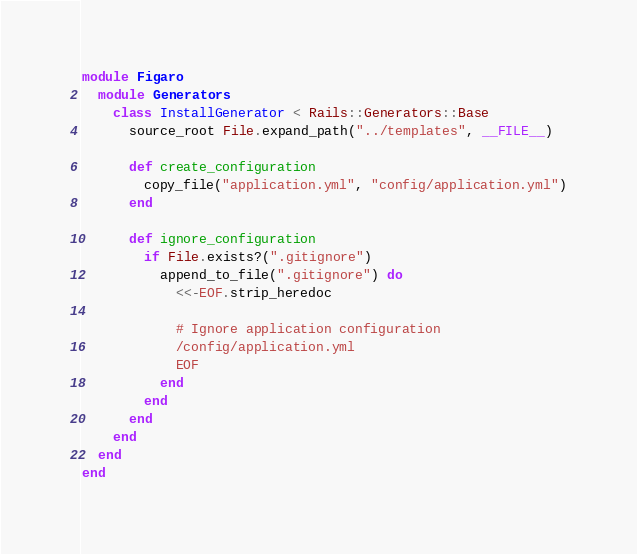Convert code to text. <code><loc_0><loc_0><loc_500><loc_500><_Ruby_>module Figaro
  module Generators
    class InstallGenerator < Rails::Generators::Base
      source_root File.expand_path("../templates", __FILE__)

      def create_configuration
        copy_file("application.yml", "config/application.yml")
      end

      def ignore_configuration
        if File.exists?(".gitignore")
          append_to_file(".gitignore") do
            <<-EOF.strip_heredoc

            # Ignore application configuration
            /config/application.yml
            EOF
          end
        end
      end
    end
  end
end
</code> 